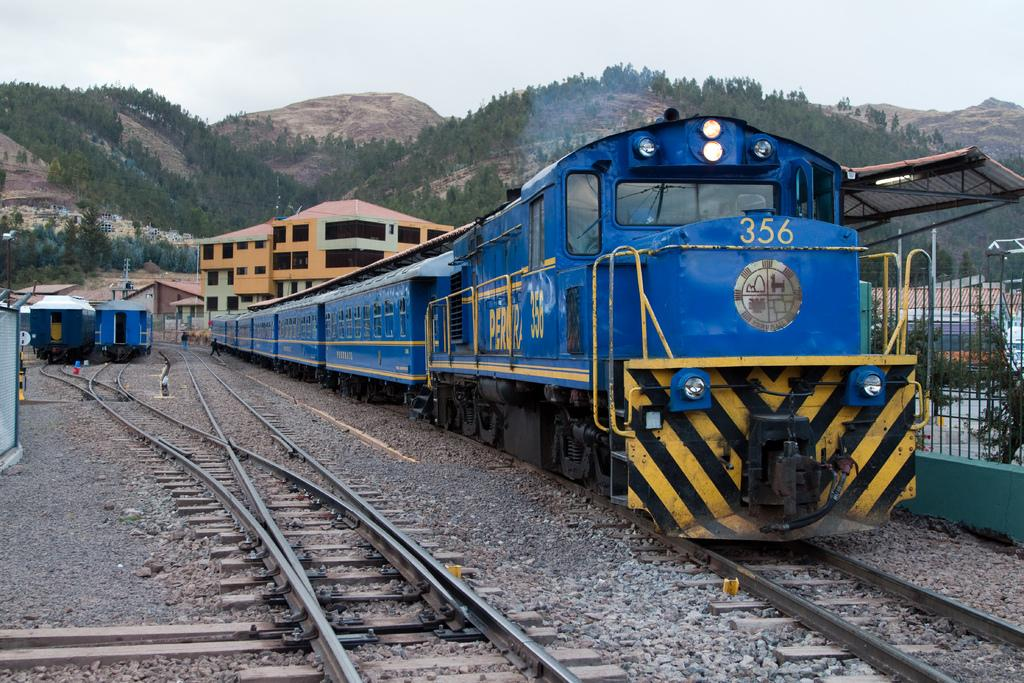Provide a one-sentence caption for the provided image. The blue train engine number 356 is pulling six rail cars behind it. 